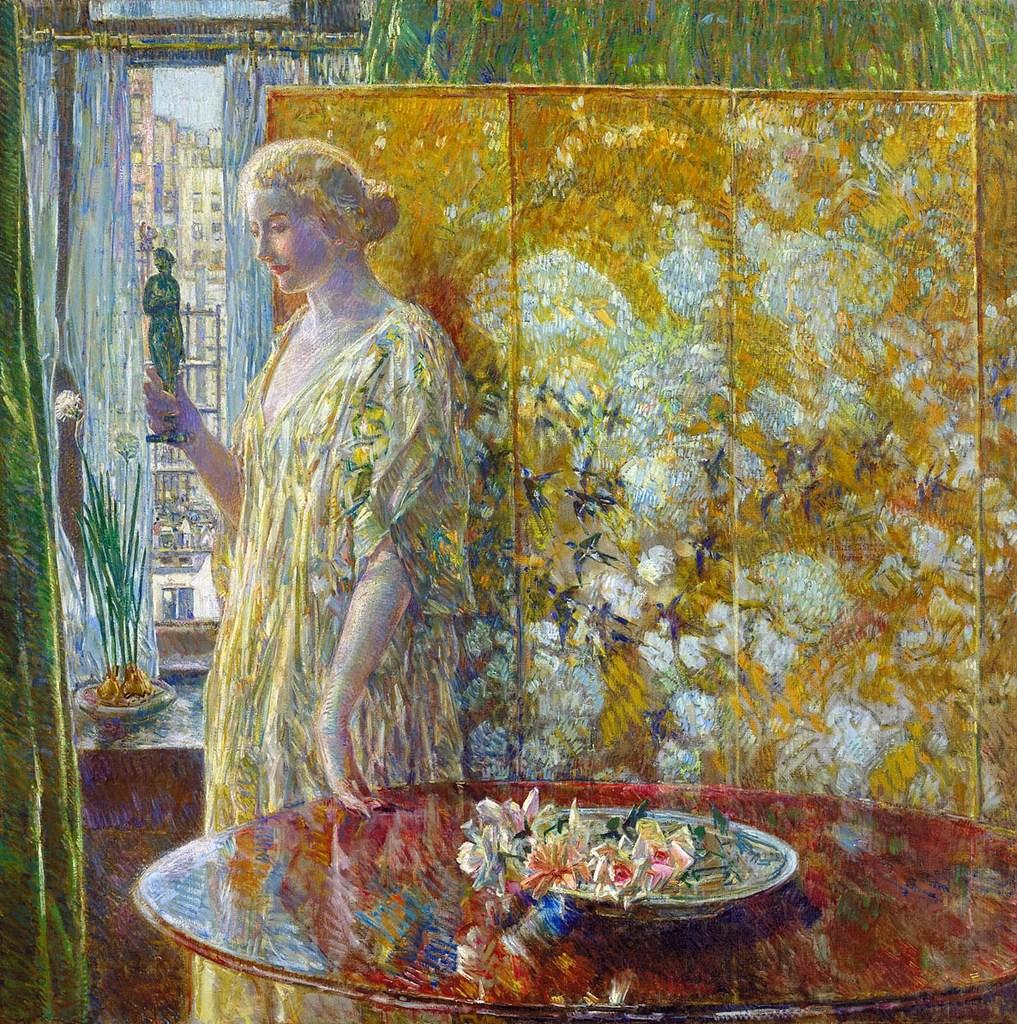What is the main subject of the art piece in the image? The art piece depicts a person holding an object. What piece of furniture is present in the image? There is a table in the image. What type of decoration is on the table? There are flowers on the table. What other items can be seen in the image? There are other objects visible in the image. How does the honey bun contribute to the art piece in the image? There is no honey bun present in the image; it is not a part of the art piece or any other element in the image. 